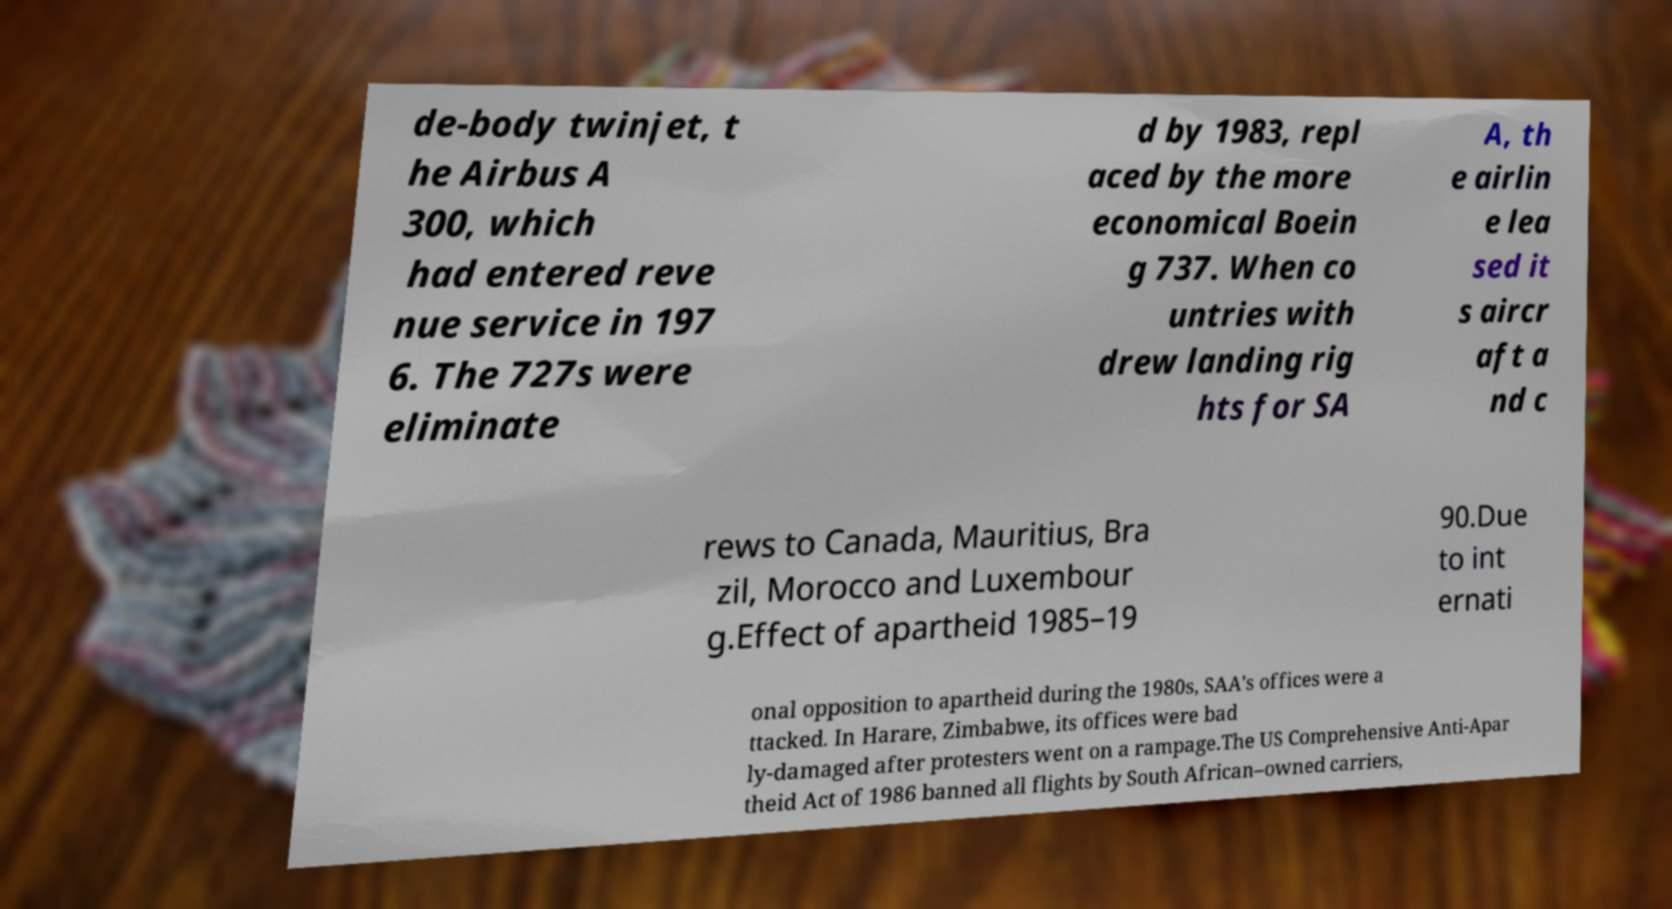Could you assist in decoding the text presented in this image and type it out clearly? de-body twinjet, t he Airbus A 300, which had entered reve nue service in 197 6. The 727s were eliminate d by 1983, repl aced by the more economical Boein g 737. When co untries with drew landing rig hts for SA A, th e airlin e lea sed it s aircr aft a nd c rews to Canada, Mauritius, Bra zil, Morocco and Luxembour g.Effect of apartheid 1985–19 90.Due to int ernati onal opposition to apartheid during the 1980s, SAA's offices were a ttacked. In Harare, Zimbabwe, its offices were bad ly-damaged after protesters went on a rampage.The US Comprehensive Anti-Apar theid Act of 1986 banned all flights by South African–owned carriers, 